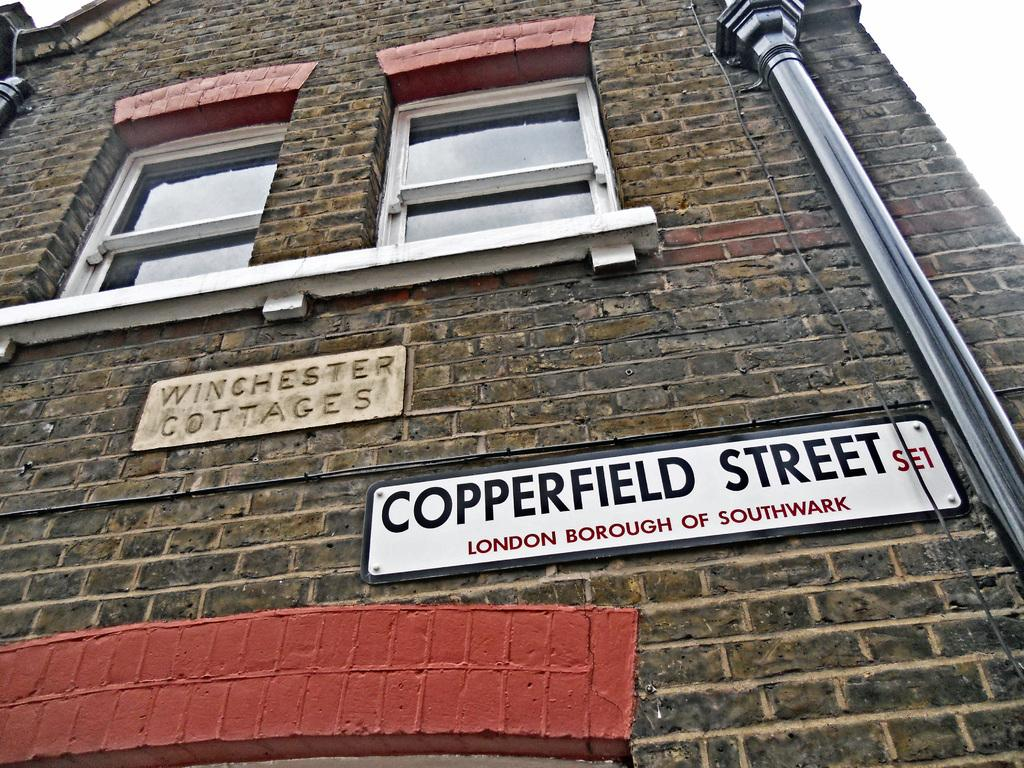What type of structure is present in the image? There is a building in the image. How many windows can be seen on the building? The building has two windows. What is located to the right of the building? There is a pole to the right of the building. What type of signage is present on the building? There are name boards on the building. What type of sponge is being used to clean the windows of the building in the image? There is no sponge or cleaning activity visible in the image. Can you see a needle being used to sew a piece of fabric on the building in the image? There is no needle or sewing activity visible in the image. 